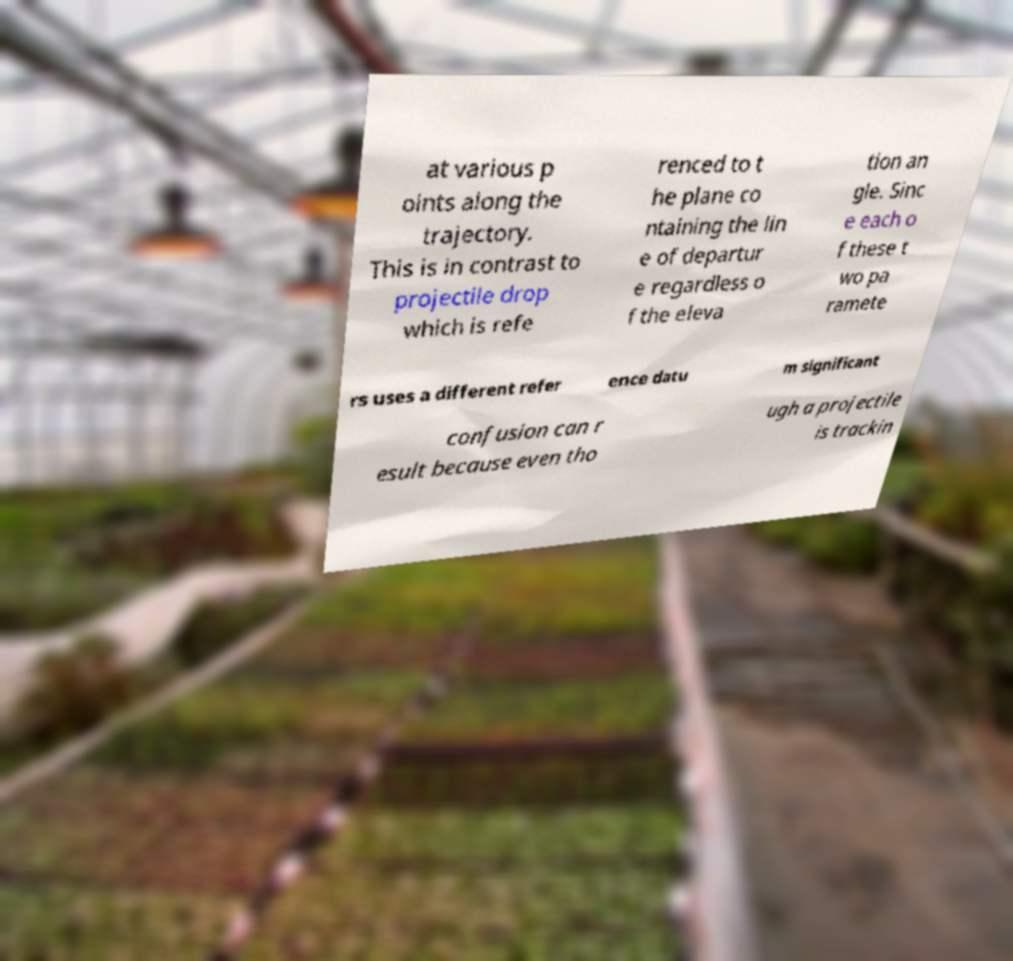Could you assist in decoding the text presented in this image and type it out clearly? at various p oints along the trajectory. This is in contrast to projectile drop which is refe renced to t he plane co ntaining the lin e of departur e regardless o f the eleva tion an gle. Sinc e each o f these t wo pa ramete rs uses a different refer ence datu m significant confusion can r esult because even tho ugh a projectile is trackin 